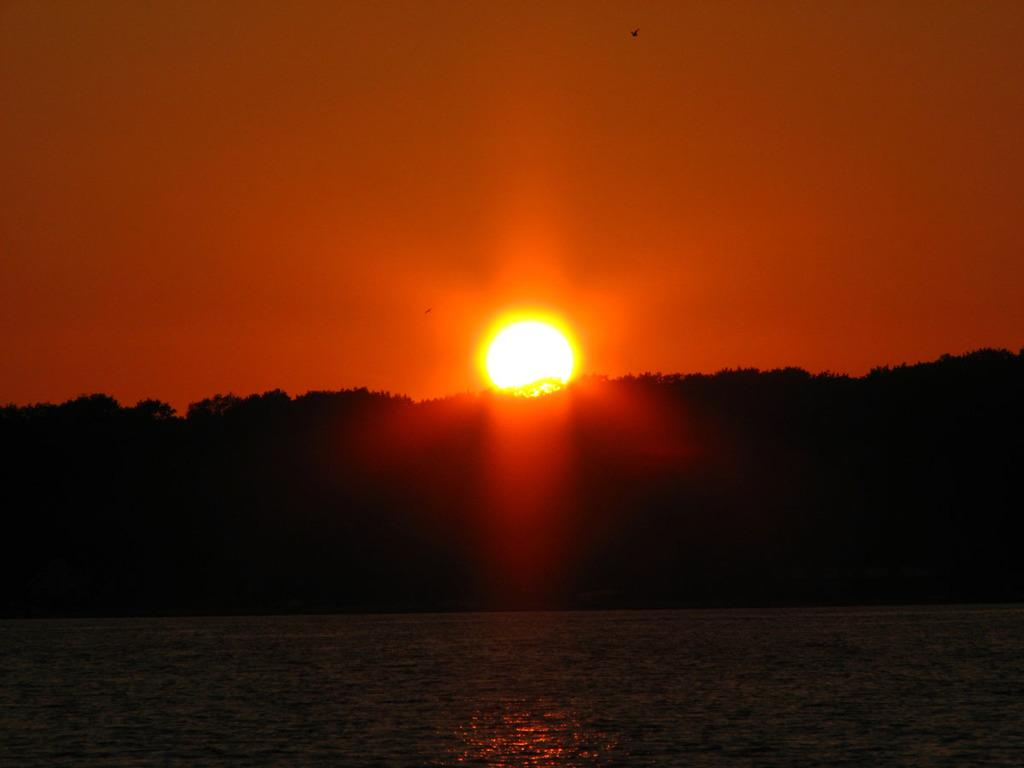What time of day is depicted in the image? The image is taken during sunset time. What type of natural environment is visible in the image? There are many trees in the image, and a river is visible at the bottom. What is visible at the top of the image? The sky is visible at the top of the image, and the sun is visible in the sky. What type of fruit is being destroyed by the river in the image? There is no fruit or destruction present in the image; it features a sunset with trees and a river. How many grapes are hanging from the trees in the image? There are no grapes visible in the image; the trees are not specified as fruit-bearing trees. 